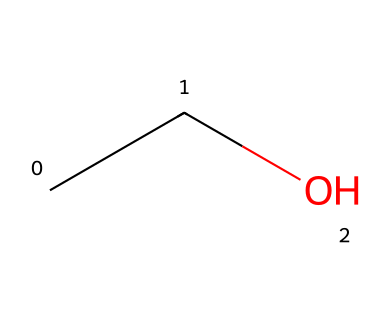What is the name of this chemical? The SMILES representation "CCO" refers to a chemical structure that is commonly known as ethanol, which is a type of alcohol.
Answer: ethanol How many carbon atoms are in this chemical? The SMILES "CCO" shows two "C" characters which represent two carbon atoms in the molecular structure of ethanol.
Answer: 2 What type of bond connects the carbon atoms in this chemical? In the representation "CCO", the two carbon atoms are connected by a single bond, which is a typical connection in aliphatic alcohols like ethanol.
Answer: single bond What is the functional group present in this chemical? The "O" in the SMILES "CCO" indicates the presence of a hydroxyl functional group (-OH), which characterizes alcohols like ethanol.
Answer: hydroxyl Is this chemical considered flammable? Yes, ethanol is known to be a flammable liquid due to its volatile nature and ability to ignite easily in the presence of an open flame.
Answer: yes What is the boiling point range for this chemical? Ethanol has a boiling point of approximately 78-79 degrees Celsius, which is typical for many small-chain alcohols.
Answer: 78-79 degrees Celsius Why does this chemical have a higher volatility compared to larger alcohols? The smaller molecular size of ethanol (as indicated by the low number of carbon and hydrogen atoms in "CCO") leads to weaker intermolecular forces, resulting in higher volatility compared to larger alcohols.
Answer: weaker intermolecular forces 